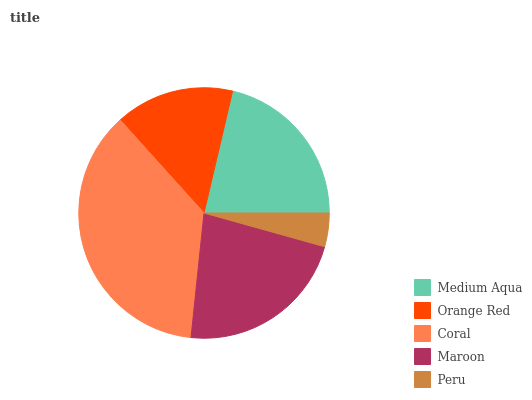Is Peru the minimum?
Answer yes or no. Yes. Is Coral the maximum?
Answer yes or no. Yes. Is Orange Red the minimum?
Answer yes or no. No. Is Orange Red the maximum?
Answer yes or no. No. Is Medium Aqua greater than Orange Red?
Answer yes or no. Yes. Is Orange Red less than Medium Aqua?
Answer yes or no. Yes. Is Orange Red greater than Medium Aqua?
Answer yes or no. No. Is Medium Aqua less than Orange Red?
Answer yes or no. No. Is Medium Aqua the high median?
Answer yes or no. Yes. Is Medium Aqua the low median?
Answer yes or no. Yes. Is Maroon the high median?
Answer yes or no. No. Is Coral the low median?
Answer yes or no. No. 